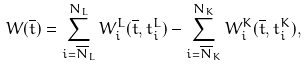<formula> <loc_0><loc_0><loc_500><loc_500>W ( { \overline { t } } ) = \sum _ { i = { { \overline { N } } _ { L } } } ^ { N _ { L } } W _ { i } ^ { L } ( { \overline { t } } , t _ { i } ^ { L } ) - \sum _ { i = { { \overline { N } } _ { K } } } ^ { N _ { K } } W _ { i } ^ { K } ( { \overline { t } } , t _ { i } ^ { K } ) ,</formula> 